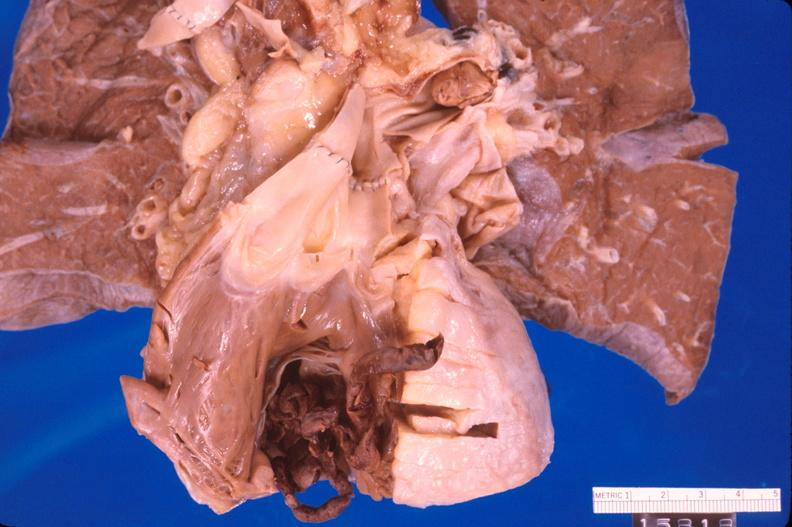does this image show thromboembolus from leg veins in right ventricle?
Answer the question using a single word or phrase. Yes 